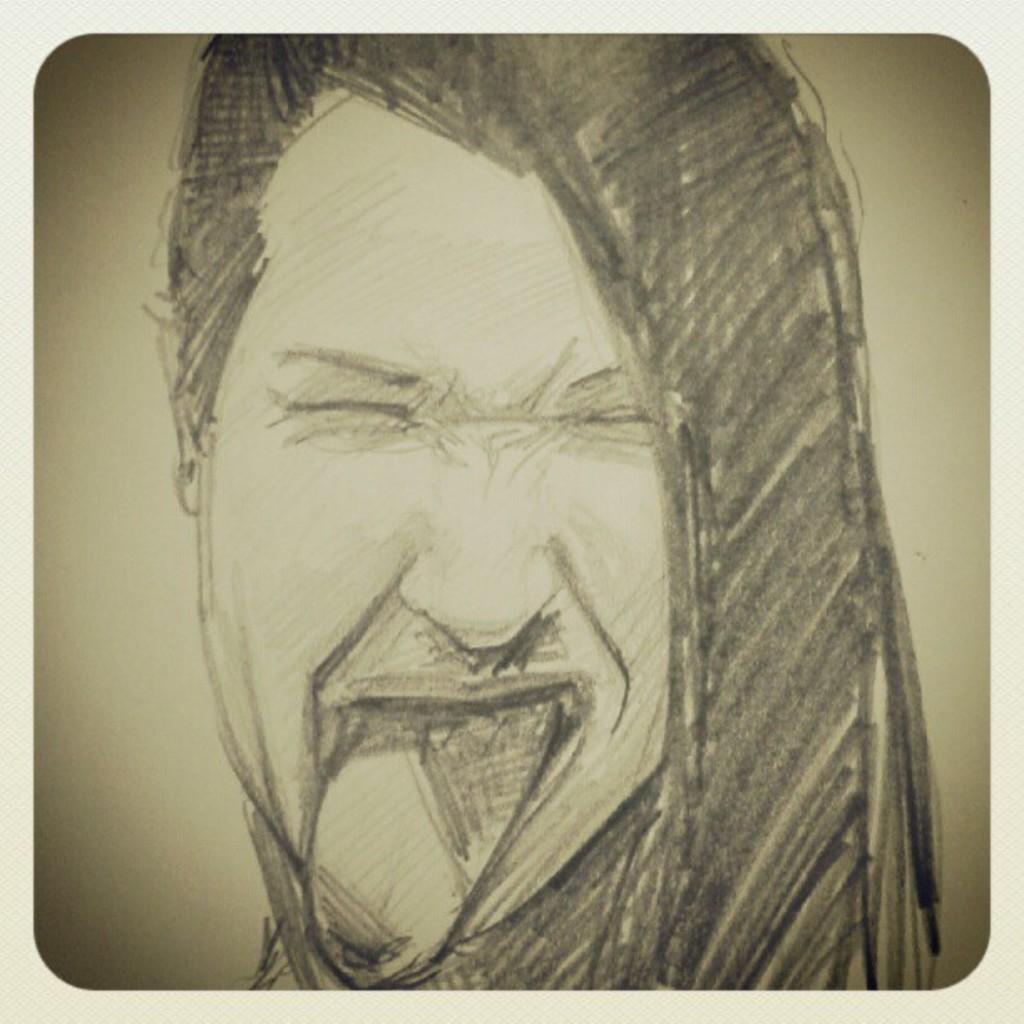How would you summarize this image in a sentence or two? In this image we can see the art of a person's face. 